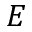Convert formula to latex. <formula><loc_0><loc_0><loc_500><loc_500>E</formula> 